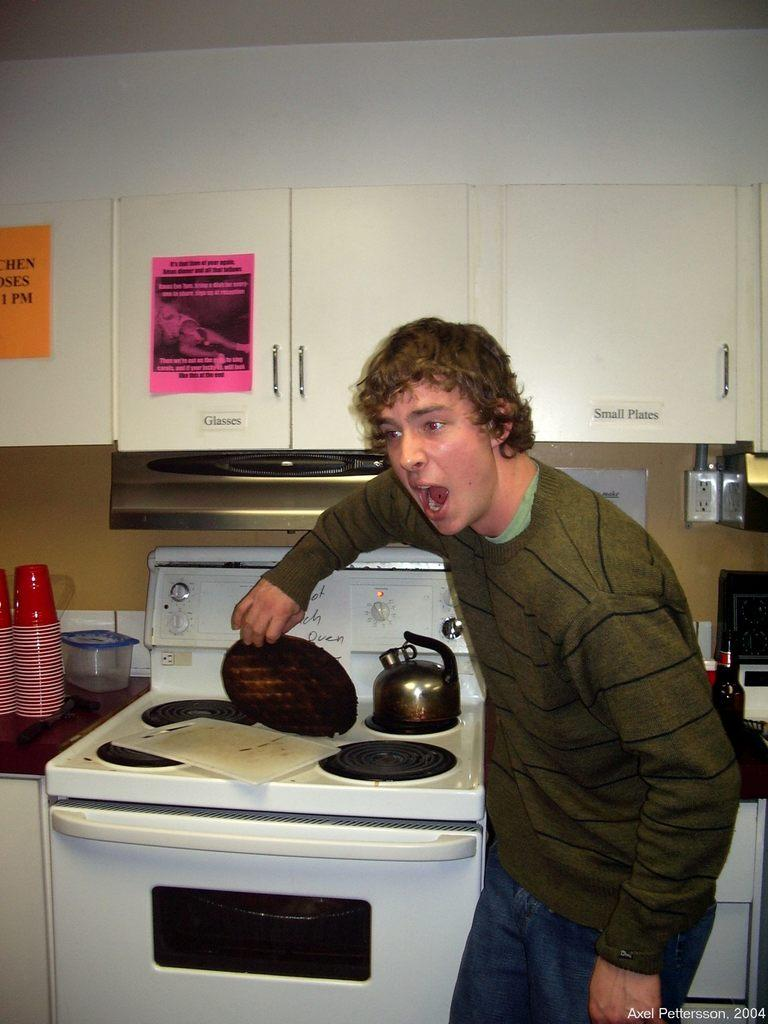Provide a one-sentence caption for the provided image. A teen burns his waffle, and the cupboards above his head indicate where to find glasses and small plates. 